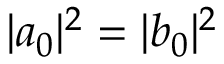<formula> <loc_0><loc_0><loc_500><loc_500>| a _ { 0 } | ^ { 2 } = | b _ { 0 } | ^ { 2 }</formula> 